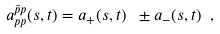<formula> <loc_0><loc_0><loc_500><loc_500>a _ { p p } ^ { \bar { p } p } ( s , t ) = a _ { + } ( s , t ) \ \pm a _ { - } ( s , t ) \ ,</formula> 